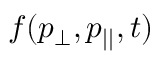Convert formula to latex. <formula><loc_0><loc_0><loc_500><loc_500>f ( p _ { \perp } , p _ { | | } , t )</formula> 